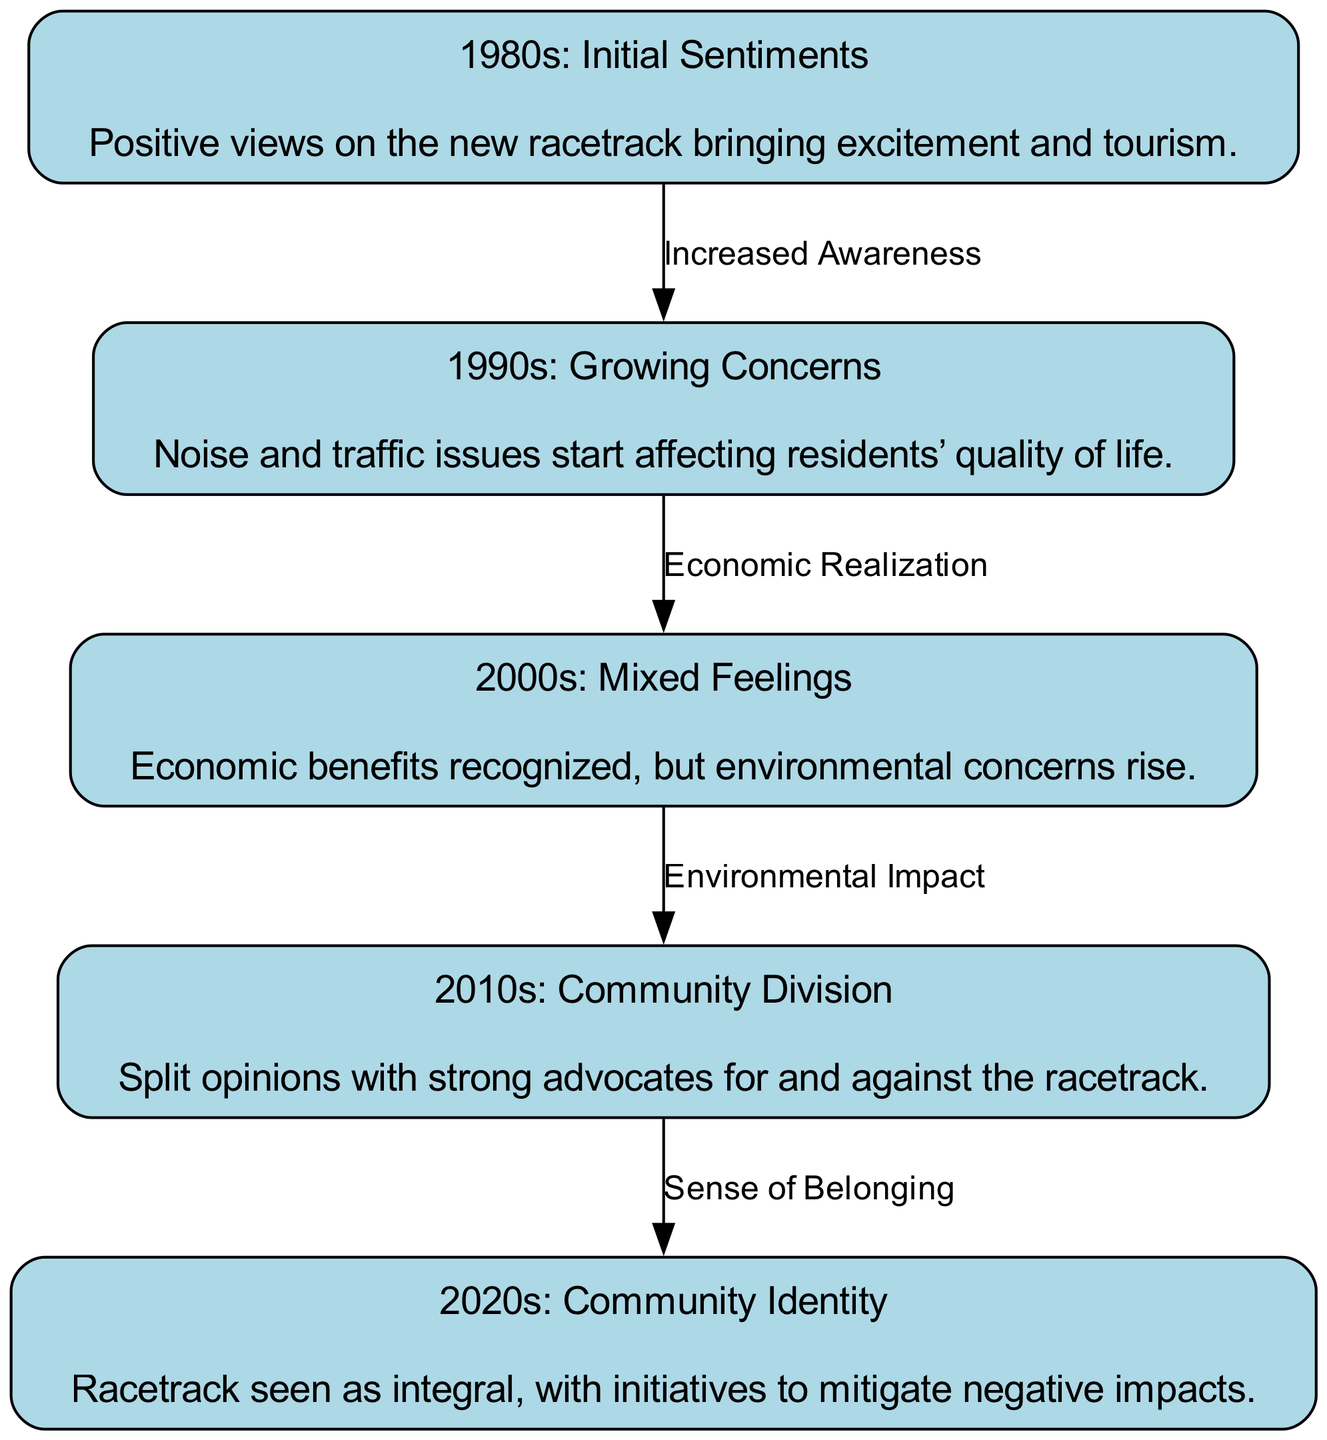What decade shows positive views on the racetrack? The diagram indicates that the 1980s are associated with initial sentiments that reflect positive views regarding the racetrack, highlighting excitement and tourism benefits.
Answer: 1980s What is the main concern in the 1990s? According to the diagram, noise and traffic issues are identified as the primary concerns affecting residents’ quality of life during the 1990s.
Answer: Noise and traffic issues How many nodes are in the diagram? By counting the distinct labeled sentiments across the decades displayed in the diagram, we can determine there are five nodes.
Answer: Five What labeling describes the relationship from the 2000s to the 2010s? The diagram shows that the relationship from the 2000s to the 2010s is characterized by the label "Environmental Impact," indicating rising environmental concerns.
Answer: Environmental Impact How did the community sentiment change from the 2010s to the 2020s? The diagram illustrates that the sentiment transitioned from a community division in the 2010s, defined by split opinions, to a sense of belonging in the 2020s, suggesting an integration of the racetrack into community identity with initiatives to mitigate negative impacts.
Answer: Sense of Belonging What is the connection labeled from the 1980s to the 1990s? The diagram denotes the connection as "Increased Awareness," indicating that the positive feelings of the 1980s led to heightened awareness of associated issues by the 1990s.
Answer: Increased Awareness Which decade reflects mixed feelings about the racetrack? The diagram identifies the 2000s as the decade reflecting mixed feelings, recognizing economic benefits while also acknowledging rising environmental concerns.
Answer: 2000s What are the two contrasting views present in the 2010s? The diagram indicates that the 2010s saw a community division, with strong advocates for and against the racetrack leading to contrasting opinions.
Answer: Strong advocates for and against What was the primary sentiment about the racetrack in the 2020s? The 2020s sentiment focuses on the racetrack being seen as integral to the community, highlighting efforts to address its negative impacts.
Answer: Integral to the community 